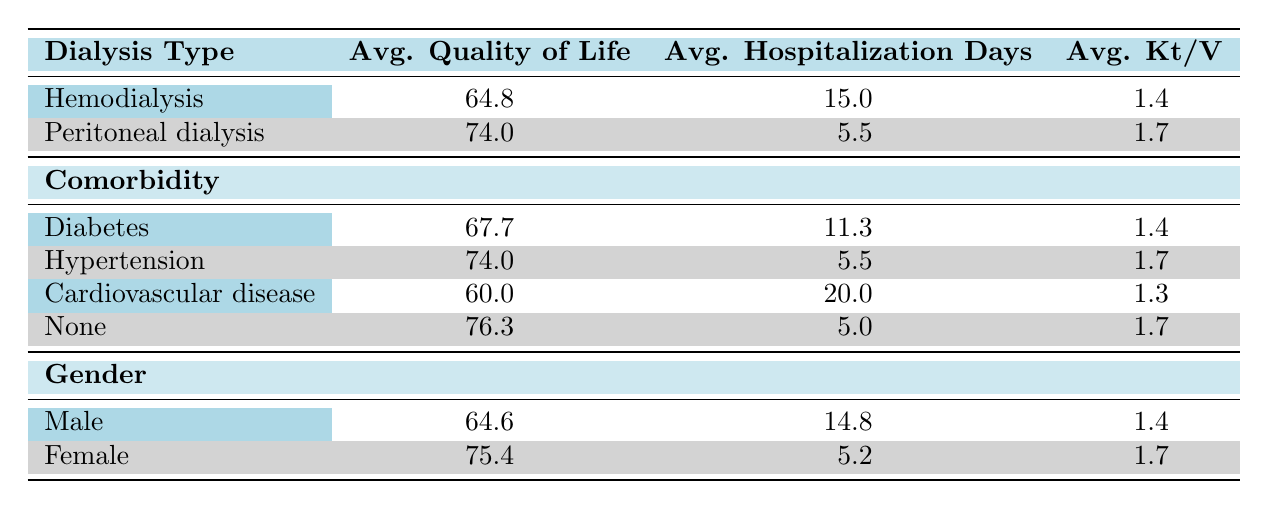What is the average quality of life score for patients undergoing Hemodialysis? From the table, the average quality of life score for patients on Hemodialysis is explicitly stated as 64.8.
Answer: 64.8 What is the average hospitalization days for patients with Cardiovascular disease? The table shows that the average hospitalization days for patients with Cardiovascular disease is listed as 20.0.
Answer: 20.0 Is the average Kt/V for Female patients higher than that for Male patients? The average Kt/V for Female patients is 1.7 while for Male patients it is 1.4. Since 1.7 is greater than 1.4, the statement is true.
Answer: Yes What is the average hospitalization duration difference between patients with Diabetes and those with None? The average hospitalization days for patients with Diabetes is 11.3, and for those with None, it is 5.0. The difference is 11.3 - 5.0 = 6.3 days.
Answer: 6.3 How many average hospitalization days do Peritoneal dialysis patients spend compared to Hemodialysis patients? The average hospitalization days for Peritoneal dialysis patients is 5.5, whereas for Hemodialysis patients it is 15.0. The difference is 15.0 - 5.5 = 9.5 days less for Peritoneal dialysis patients.
Answer: 9.5 What is the highest average quality of life score among patients with different comorbidities? From the table, the highest average quality of life score is 76.3 for patients with No comorbidity.
Answer: 76.3 Do patients with Hypertension have higher average quality of life scores than those with Diabetes? The average quality of life score for patients with Hypertension is 74.0, while for those with Diabetes it is 67.7. Since 74.0 is greater than 67.7, the statement is true.
Answer: Yes What is the overall average Kt/V for all patients listed in the table? To find the overall average Kt/V, we look at the averages for both dialysis types: Hemodialysis has an average Kt/V of 1.4, and Peritoneal dialysis is 1.7. The average is (1.4 + 1.7) / 2 = 1.55.
Answer: 1.55 What is the average quality of life score for patients receiving Peritoneal dialysis? The average quality of life score for patients undergoing Peritoneal dialysis is explicitly stated in the table as 74.0.
Answer: 74.0 